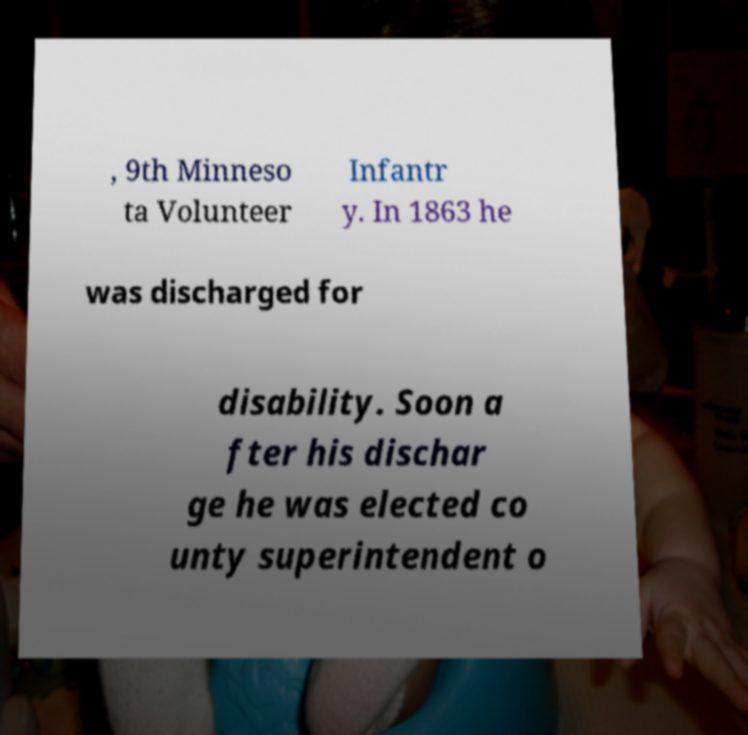What messages or text are displayed in this image? I need them in a readable, typed format. , 9th Minneso ta Volunteer Infantr y. In 1863 he was discharged for disability. Soon a fter his dischar ge he was elected co unty superintendent o 